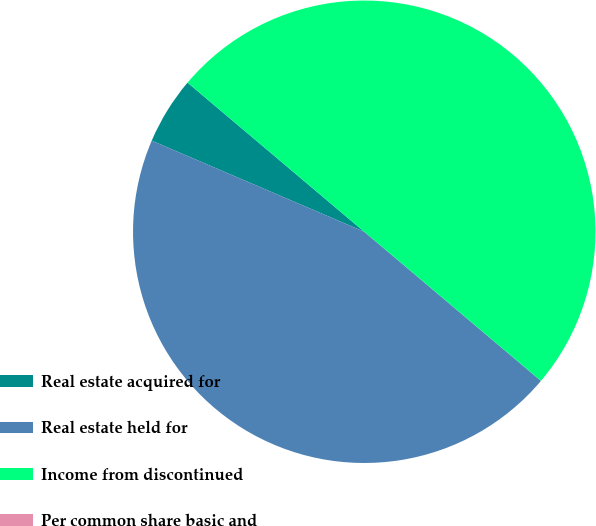<chart> <loc_0><loc_0><loc_500><loc_500><pie_chart><fcel>Real estate acquired for<fcel>Real estate held for<fcel>Income from discontinued<fcel>Per common share basic and<nl><fcel>4.71%<fcel>45.29%<fcel>50.0%<fcel>0.0%<nl></chart> 